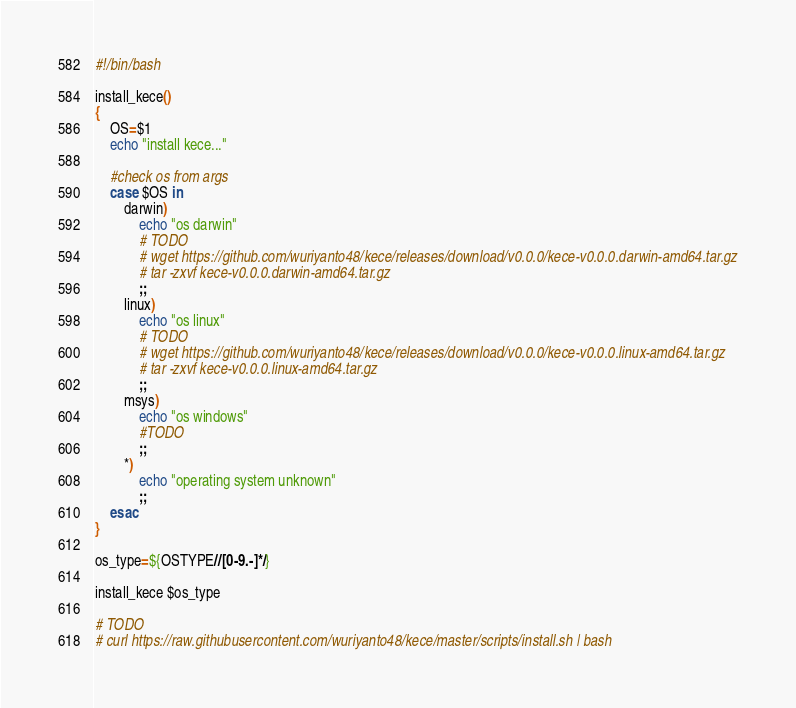Convert code to text. <code><loc_0><loc_0><loc_500><loc_500><_Bash_>#!/bin/bash

install_kece()
{
    OS=$1
    echo "install kece..."

    #check os from args
    case $OS in
        darwin)
            echo "os darwin"
            # TODO
            # wget https://github.com/wuriyanto48/kece/releases/download/v0.0.0/kece-v0.0.0.darwin-amd64.tar.gz
            # tar -zxvf kece-v0.0.0.darwin-amd64.tar.gz
            ;;
        linux)
            echo "os linux"
            # TODO
            # wget https://github.com/wuriyanto48/kece/releases/download/v0.0.0/kece-v0.0.0.linux-amd64.tar.gz
            # tar -zxvf kece-v0.0.0.linux-amd64.tar.gz
            ;;
        msys)
            echo "os windows"
            #TODO
            ;;
        *)
            echo "operating system unknown"
            ;;
    esac
}

os_type=${OSTYPE//[0-9.-]*/}

install_kece $os_type

# TODO
# curl https://raw.githubusercontent.com/wuriyanto48/kece/master/scripts/install.sh | bash
</code> 